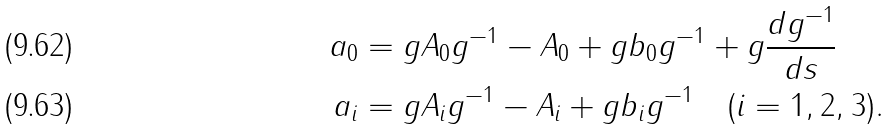Convert formula to latex. <formula><loc_0><loc_0><loc_500><loc_500>a _ { 0 } & = g A _ { 0 } g ^ { - 1 } - A _ { 0 } + g b _ { 0 } g ^ { - 1 } + g \frac { d g ^ { - 1 } } { d s } \\ a _ { i } & = g A _ { i } g ^ { - 1 } - A _ { i } + g b _ { i } g ^ { - 1 } \quad ( i = 1 , 2 , 3 ) .</formula> 